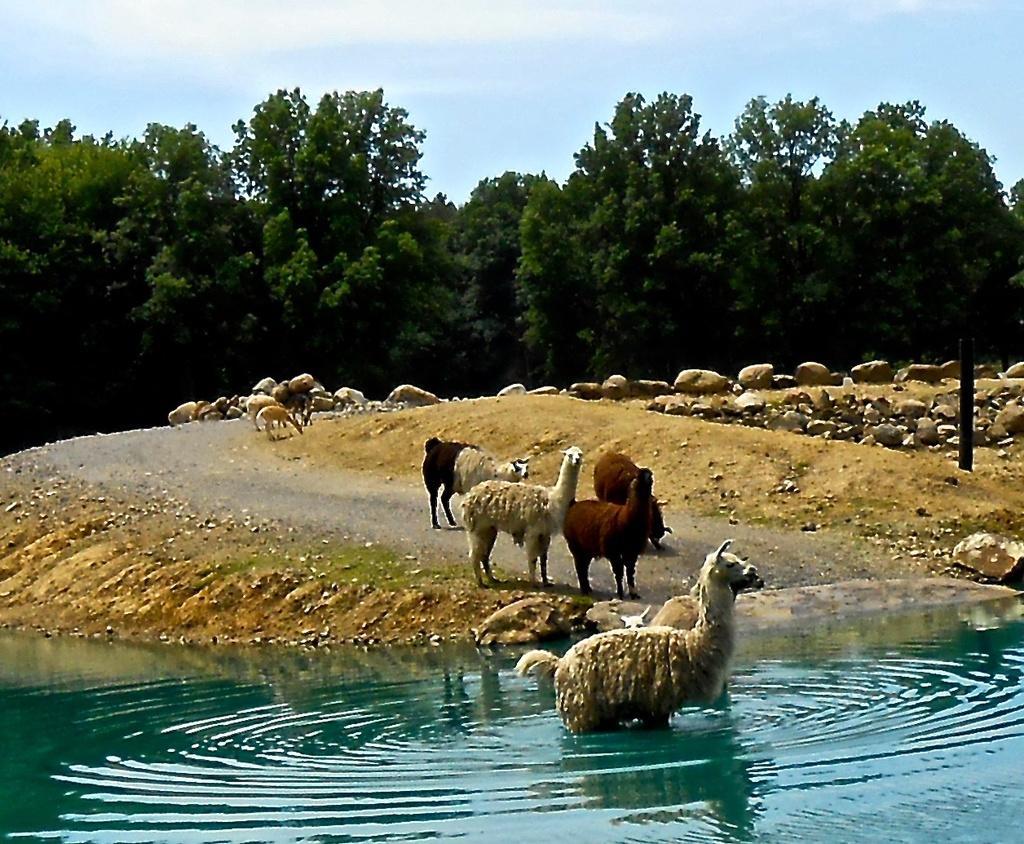Could you give a brief overview of what you see in this image? In the center of the image see some animals are there. At the bottom of the image water is there. In the middle of the image ground is there. At the top of the image sky is there. In the background of the image trees are present. 